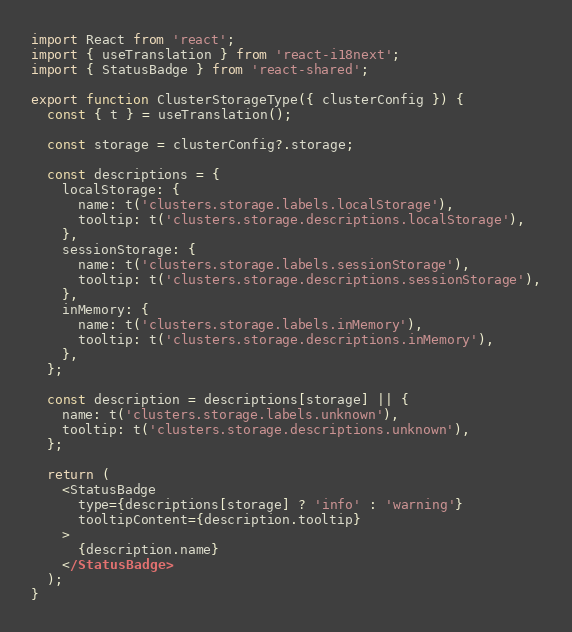<code> <loc_0><loc_0><loc_500><loc_500><_JavaScript_>import React from 'react';
import { useTranslation } from 'react-i18next';
import { StatusBadge } from 'react-shared';

export function ClusterStorageType({ clusterConfig }) {
  const { t } = useTranslation();

  const storage = clusterConfig?.storage;

  const descriptions = {
    localStorage: {
      name: t('clusters.storage.labels.localStorage'),
      tooltip: t('clusters.storage.descriptions.localStorage'),
    },
    sessionStorage: {
      name: t('clusters.storage.labels.sessionStorage'),
      tooltip: t('clusters.storage.descriptions.sessionStorage'),
    },
    inMemory: {
      name: t('clusters.storage.labels.inMemory'),
      tooltip: t('clusters.storage.descriptions.inMemory'),
    },
  };

  const description = descriptions[storage] || {
    name: t('clusters.storage.labels.unknown'),
    tooltip: t('clusters.storage.descriptions.unknown'),
  };

  return (
    <StatusBadge
      type={descriptions[storage] ? 'info' : 'warning'}
      tooltipContent={description.tooltip}
    >
      {description.name}
    </StatusBadge>
  );
}
</code> 